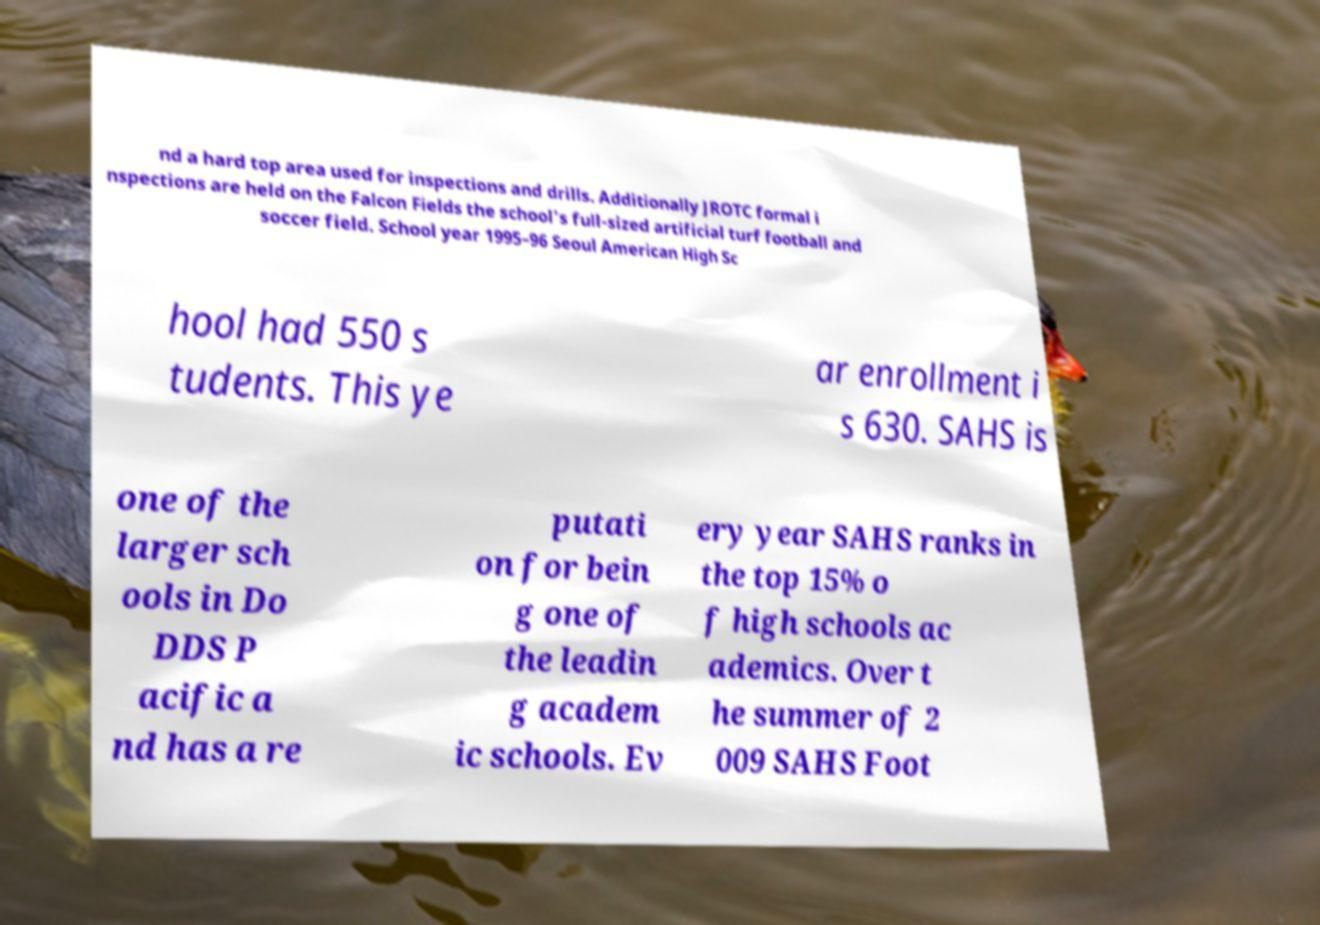Can you read and provide the text displayed in the image?This photo seems to have some interesting text. Can you extract and type it out for me? nd a hard top area used for inspections and drills. Additionally JROTC formal i nspections are held on the Falcon Fields the school's full-sized artificial turf football and soccer field. School year 1995–96 Seoul American High Sc hool had 550 s tudents. This ye ar enrollment i s 630. SAHS is one of the larger sch ools in Do DDS P acific a nd has a re putati on for bein g one of the leadin g academ ic schools. Ev ery year SAHS ranks in the top 15% o f high schools ac ademics. Over t he summer of 2 009 SAHS Foot 